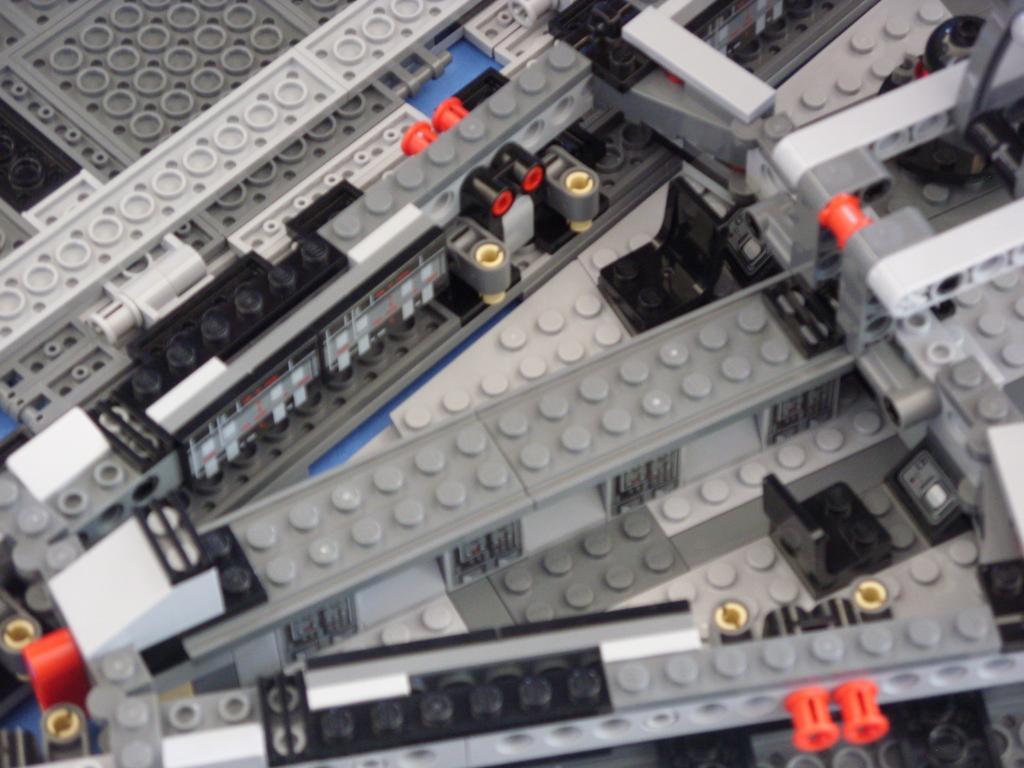How would you summarize this image in a sentence or two? In the center of the image there are lego toys. 